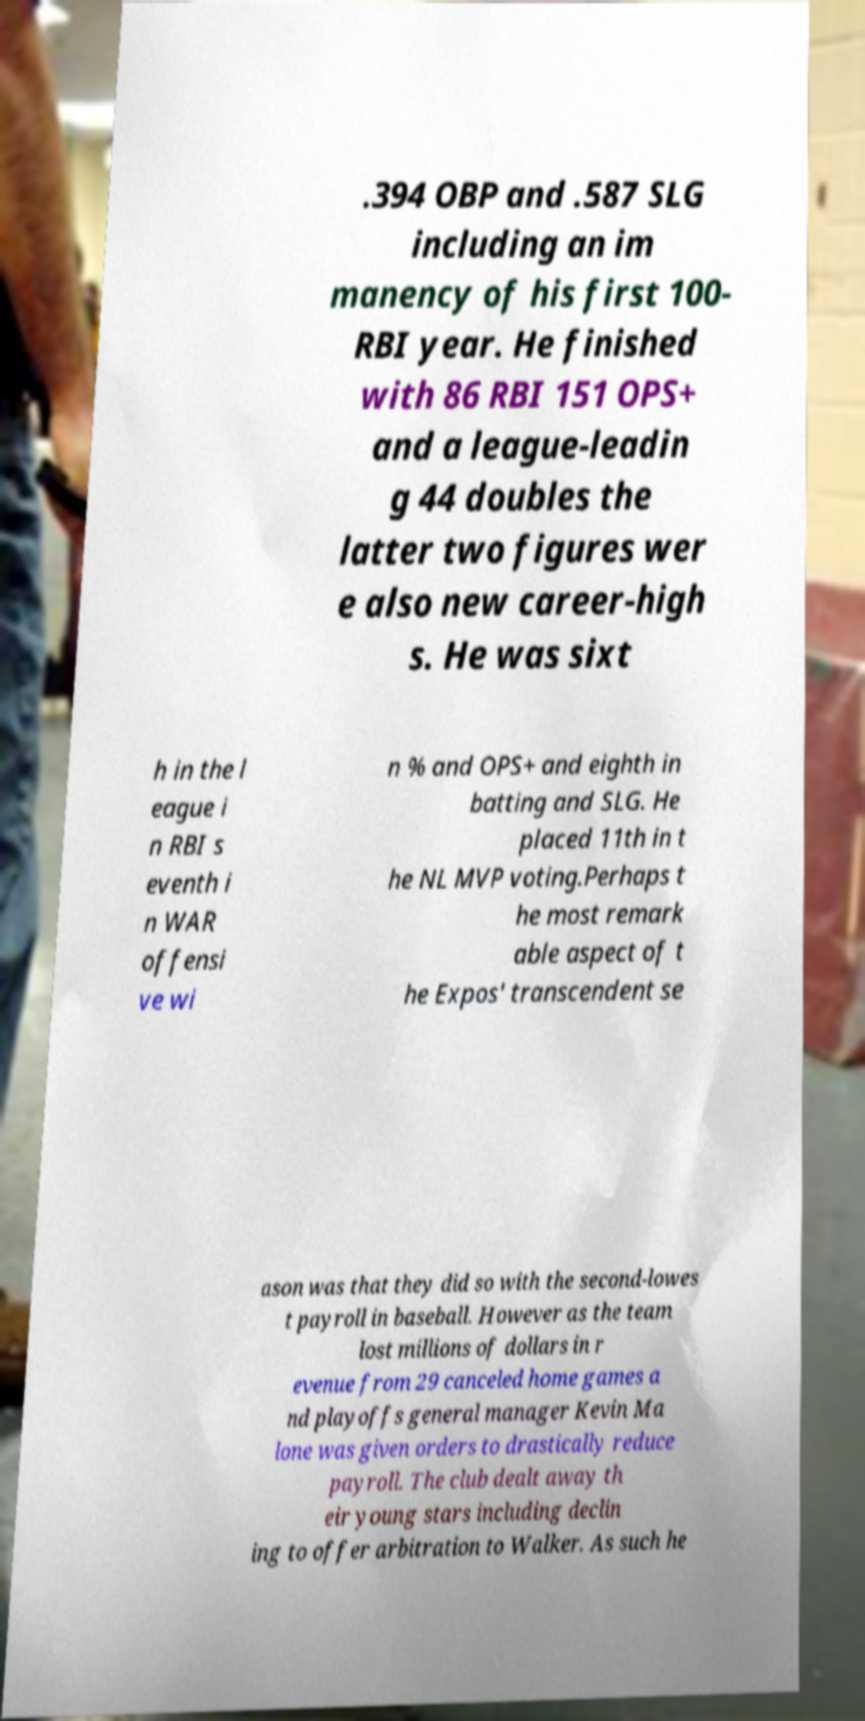Could you extract and type out the text from this image? .394 OBP and .587 SLG including an im manency of his first 100- RBI year. He finished with 86 RBI 151 OPS+ and a league-leadin g 44 doubles the latter two figures wer e also new career-high s. He was sixt h in the l eague i n RBI s eventh i n WAR offensi ve wi n % and OPS+ and eighth in batting and SLG. He placed 11th in t he NL MVP voting.Perhaps t he most remark able aspect of t he Expos' transcendent se ason was that they did so with the second-lowes t payroll in baseball. However as the team lost millions of dollars in r evenue from 29 canceled home games a nd playoffs general manager Kevin Ma lone was given orders to drastically reduce payroll. The club dealt away th eir young stars including declin ing to offer arbitration to Walker. As such he 